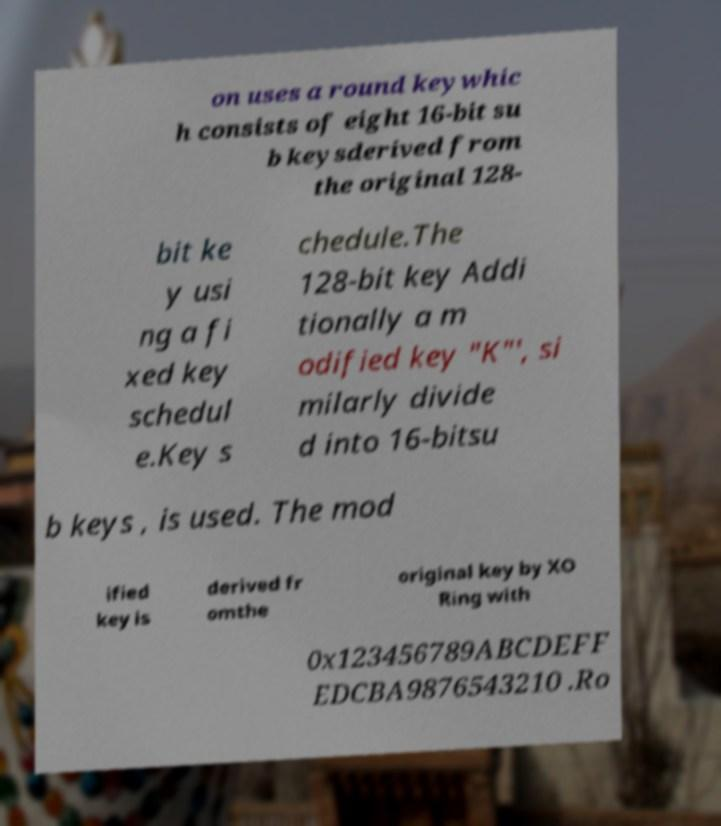Can you read and provide the text displayed in the image?This photo seems to have some interesting text. Can you extract and type it out for me? on uses a round keywhic h consists of eight 16-bit su b keysderived from the original 128- bit ke y usi ng a fi xed key schedul e.Key s chedule.The 128-bit key Addi tionally a m odified key "K"', si milarly divide d into 16-bitsu b keys , is used. The mod ified key is derived fr omthe original key by XO Ring with 0x123456789ABCDEFF EDCBA9876543210 .Ro 